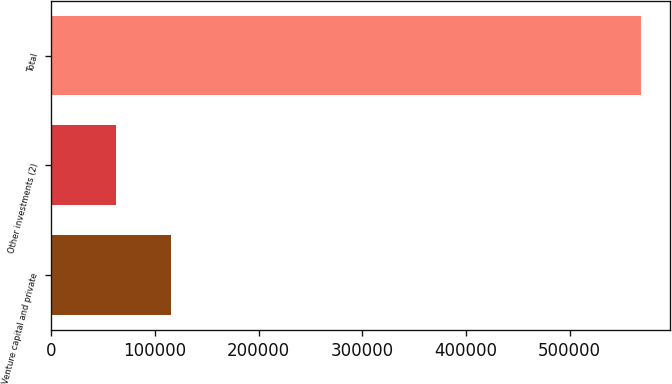Convert chart to OTSL. <chart><loc_0><loc_0><loc_500><loc_500><bar_chart><fcel>Venture capital and private<fcel>Other investments (2)<fcel>Total<nl><fcel>115337<fcel>62363<fcel>568947<nl></chart> 